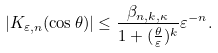Convert formula to latex. <formula><loc_0><loc_0><loc_500><loc_500>| K _ { \varepsilon , n } ( \cos \theta ) | \leq \frac { \beta _ { n , k , \kappa } } { 1 + ( \frac { \theta } { \varepsilon } ) ^ { k } } \varepsilon ^ { - n } .</formula> 